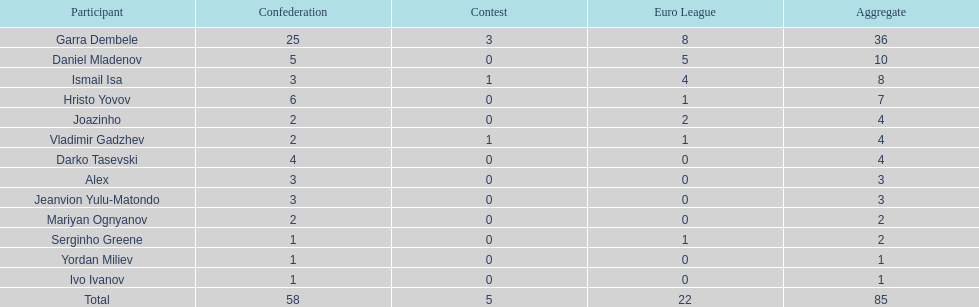Which players only scored one goal? Serginho Greene, Yordan Miliev, Ivo Ivanov. 